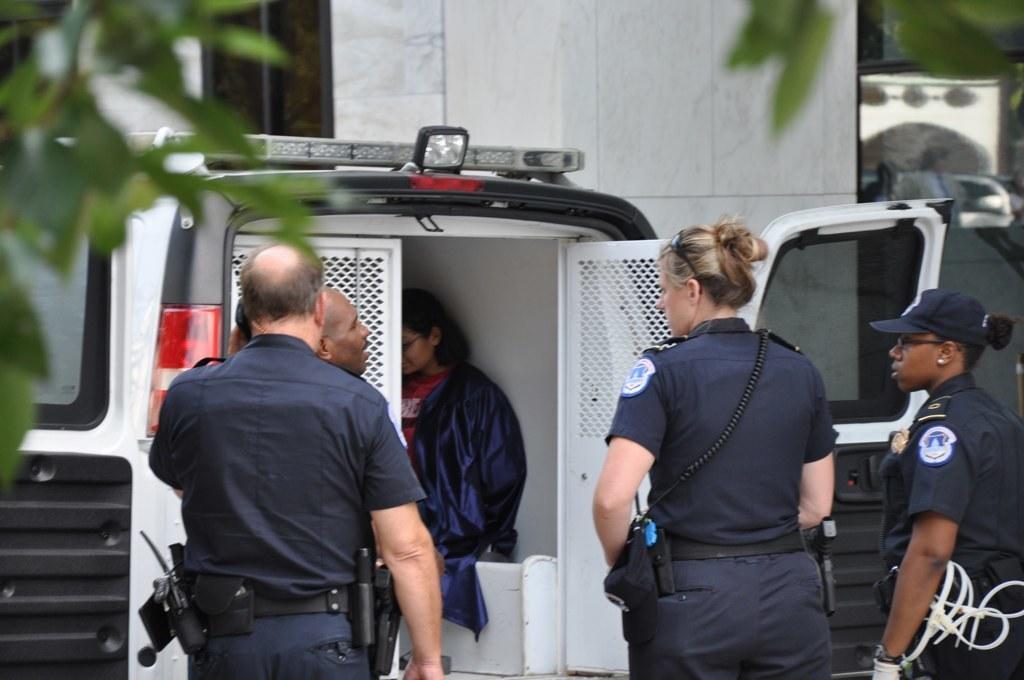Describe this image in one or two sentences. In this picture we can see five persons and a van in the front, in the background there is a wall, we can see leaves at the left top of the picture. 